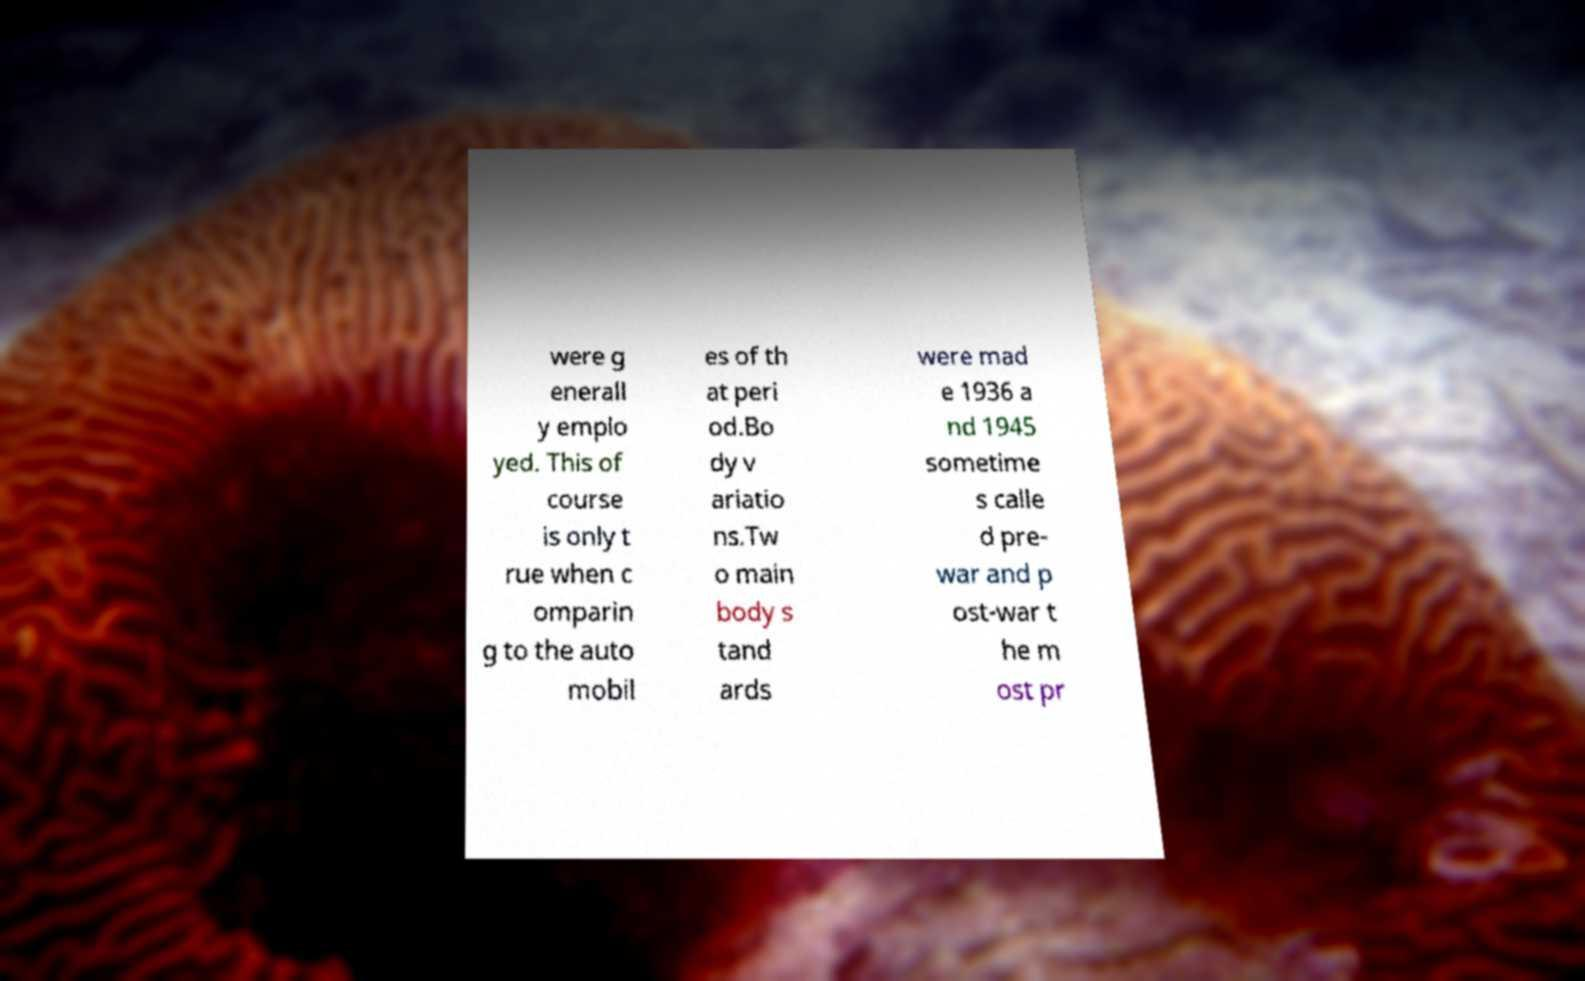Could you extract and type out the text from this image? were g enerall y emplo yed. This of course is only t rue when c omparin g to the auto mobil es of th at peri od.Bo dy v ariatio ns.Tw o main body s tand ards were mad e 1936 a nd 1945 sometime s calle d pre- war and p ost-war t he m ost pr 